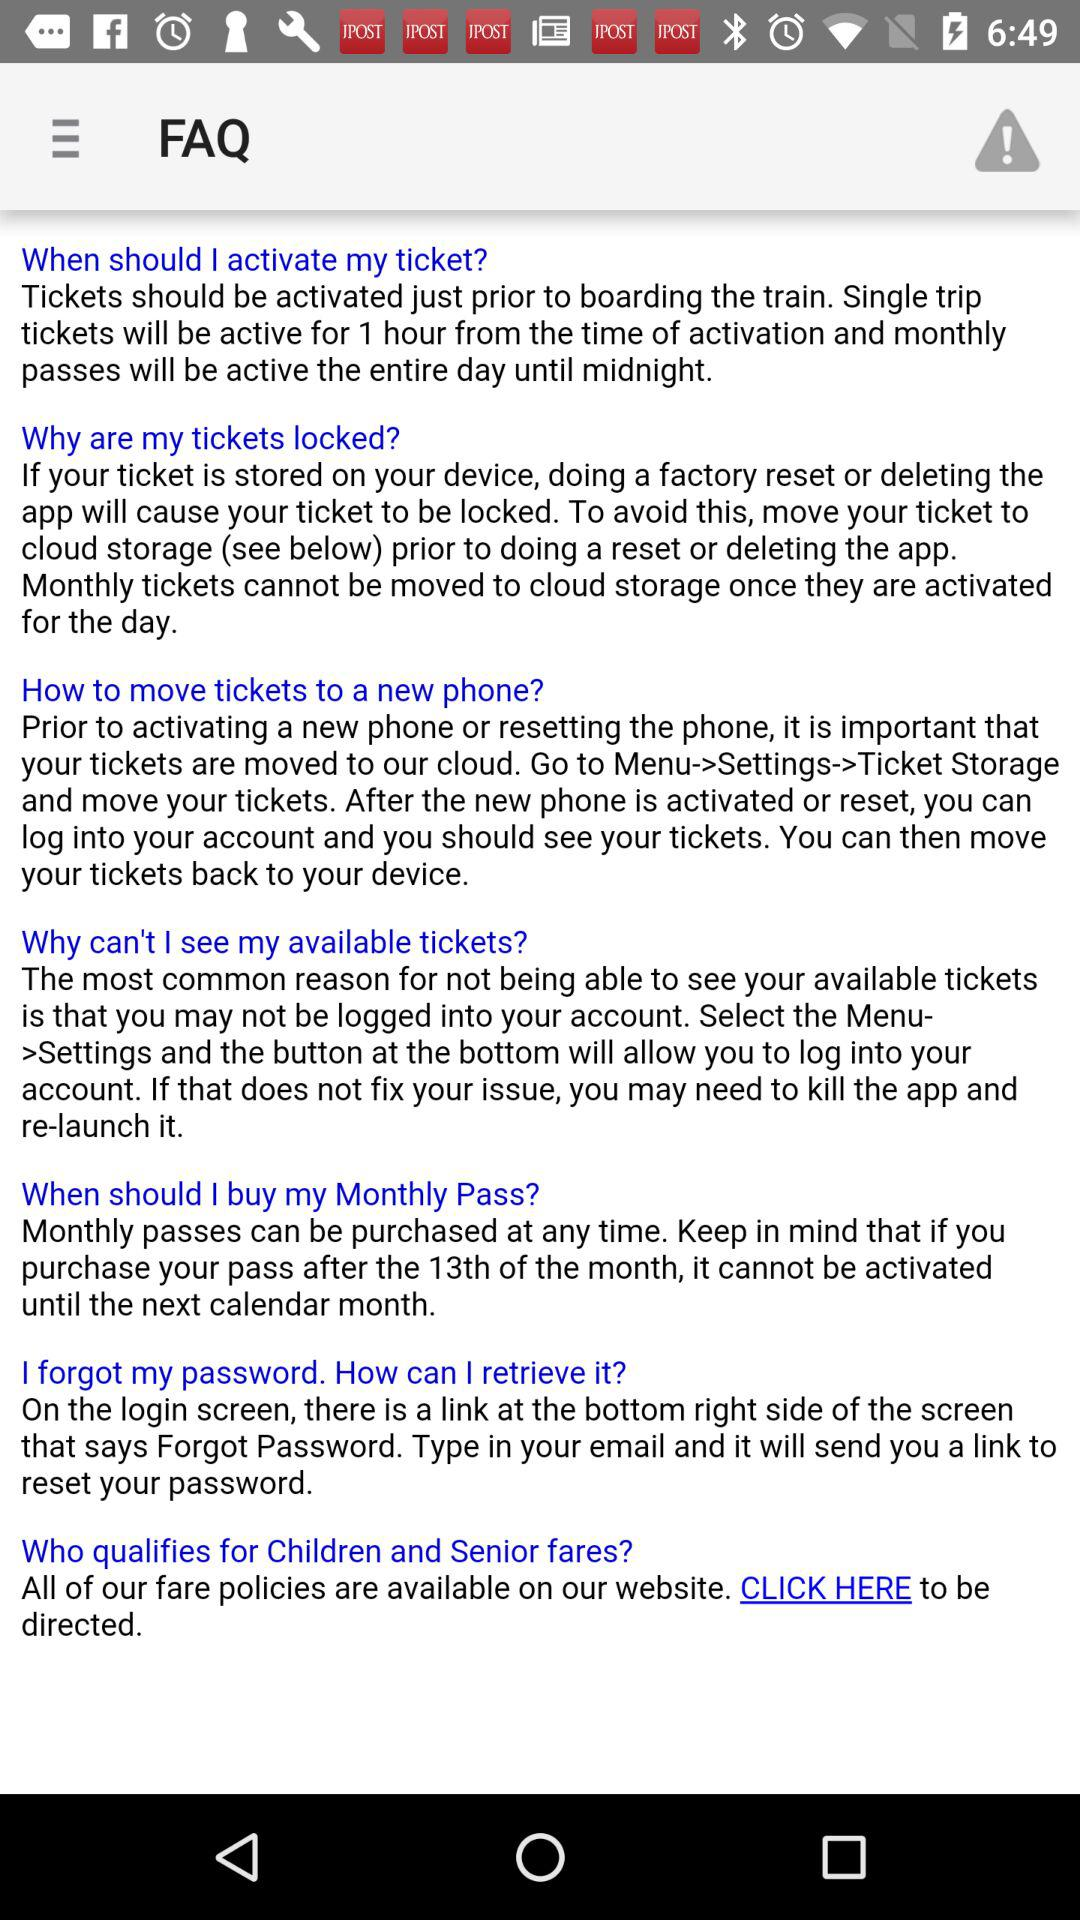What are the frequently asked questions (FAQs)? The frequently asked questions (FAQs) are "When should I activate my ticket?"; "Why are my tickets locked?"; "How to move tickets to a new phone?"; "Why can't I see my available tickets?"; "When should I buy my Monthly Pass?"; "I forgot my password. How can I retrieve it?" and "Who qualifies for Children and Senior fares?". 